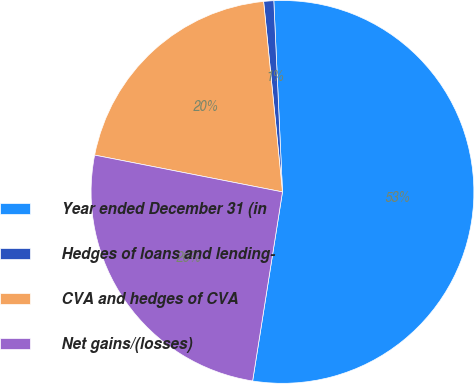Convert chart. <chart><loc_0><loc_0><loc_500><loc_500><pie_chart><fcel>Year ended December 31 (in<fcel>Hedges of loans and lending-<fcel>CVA and hedges of CVA<fcel>Net gains/(losses)<nl><fcel>53.22%<fcel>0.85%<fcel>20.35%<fcel>25.59%<nl></chart> 